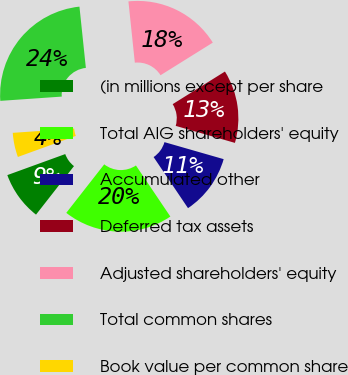Convert chart to OTSL. <chart><loc_0><loc_0><loc_500><loc_500><pie_chart><fcel>(in millions except per share<fcel>Total AIG shareholders' equity<fcel>Accumulated other<fcel>Deferred tax assets<fcel>Adjusted shareholders' equity<fcel>Total common shares<fcel>Book value per common share<nl><fcel>8.89%<fcel>20.0%<fcel>11.11%<fcel>13.33%<fcel>17.78%<fcel>24.44%<fcel>4.44%<nl></chart> 